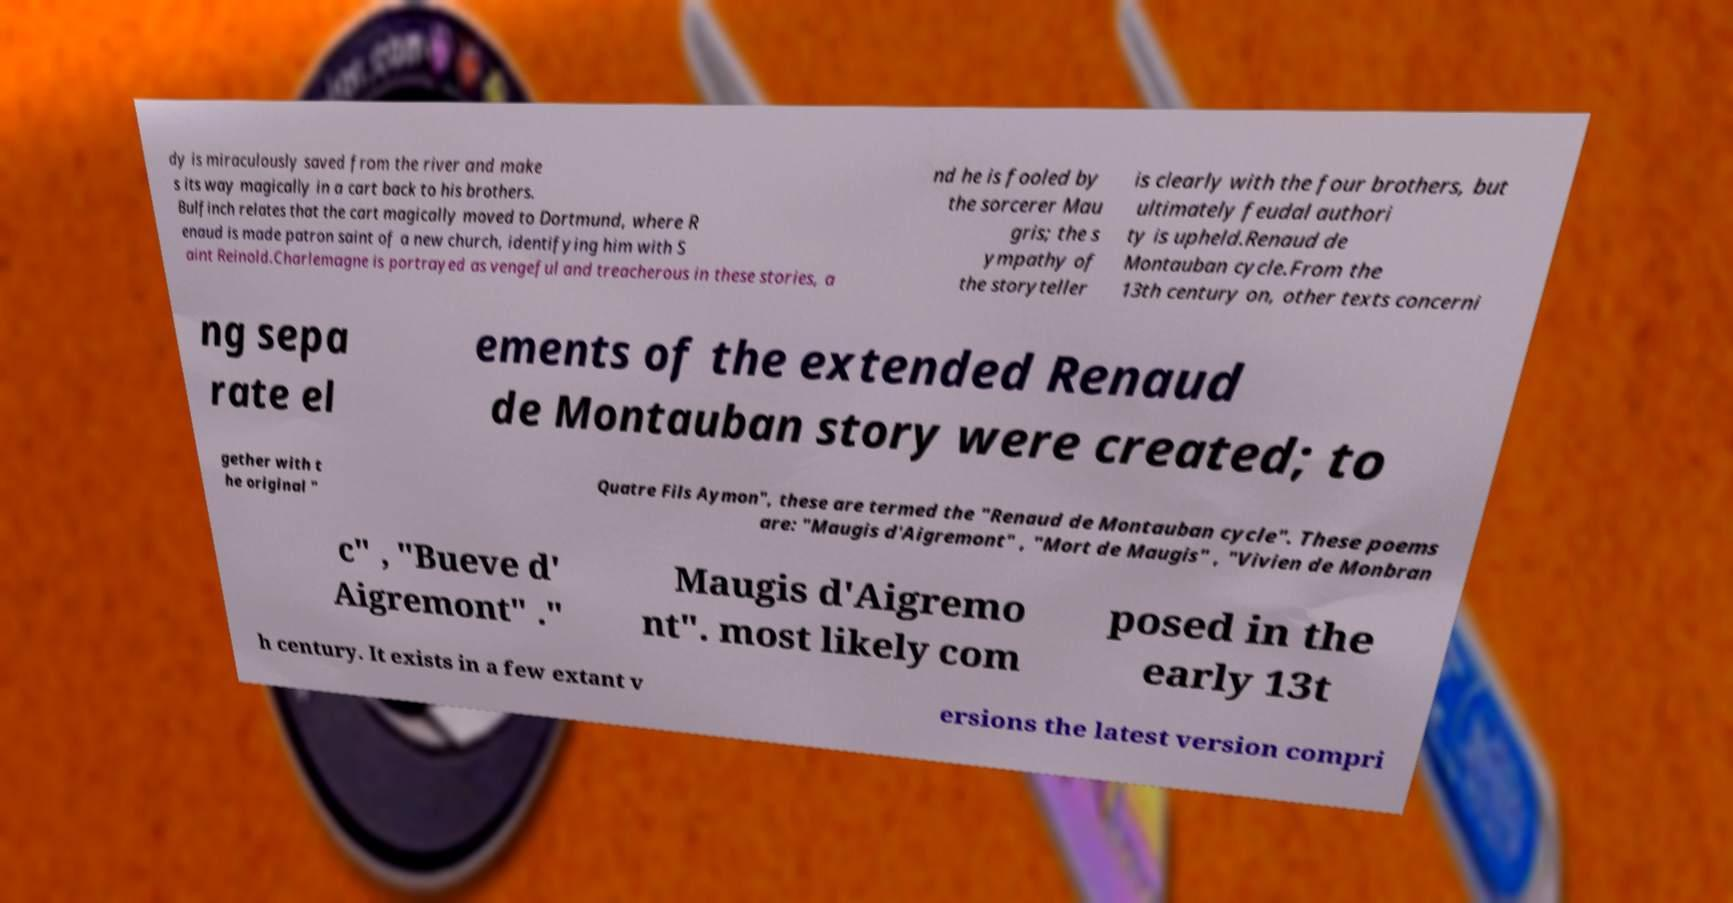Please read and relay the text visible in this image. What does it say? dy is miraculously saved from the river and make s its way magically in a cart back to his brothers. Bulfinch relates that the cart magically moved to Dortmund, where R enaud is made patron saint of a new church, identifying him with S aint Reinold.Charlemagne is portrayed as vengeful and treacherous in these stories, a nd he is fooled by the sorcerer Mau gris; the s ympathy of the storyteller is clearly with the four brothers, but ultimately feudal authori ty is upheld.Renaud de Montauban cycle.From the 13th century on, other texts concerni ng sepa rate el ements of the extended Renaud de Montauban story were created; to gether with t he original " Quatre Fils Aymon", these are termed the "Renaud de Montauban cycle". These poems are: "Maugis d'Aigremont" , "Mort de Maugis" , "Vivien de Monbran c" , "Bueve d' Aigremont" ." Maugis d'Aigremo nt". most likely com posed in the early 13t h century. It exists in a few extant v ersions the latest version compri 